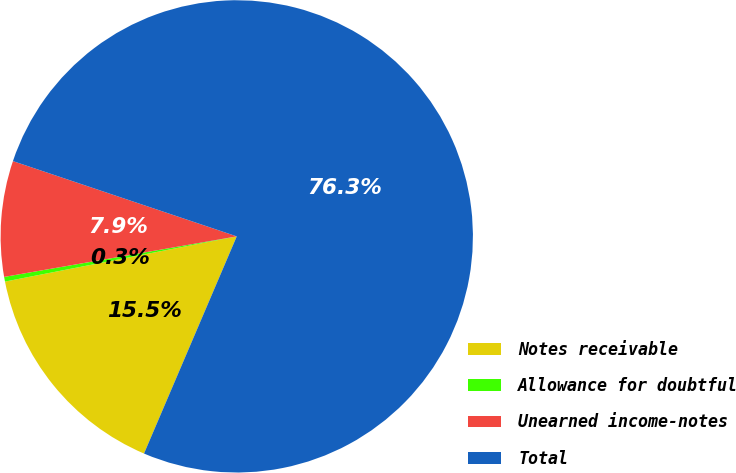<chart> <loc_0><loc_0><loc_500><loc_500><pie_chart><fcel>Notes receivable<fcel>Allowance for doubtful<fcel>Unearned income-notes<fcel>Total<nl><fcel>15.51%<fcel>0.32%<fcel>7.91%<fcel>76.26%<nl></chart> 